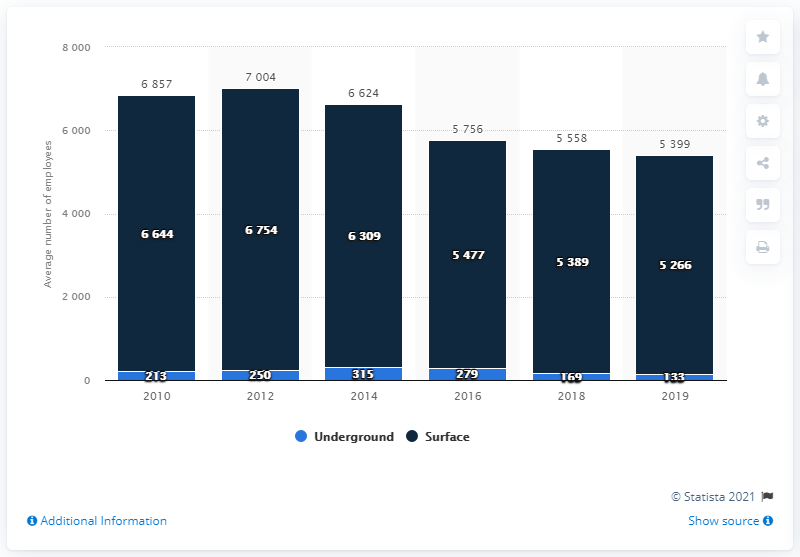Specify some key components in this picture. In 2019, a total of 133 employees were working in underground mines in Wyoming. 